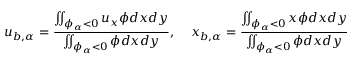<formula> <loc_0><loc_0><loc_500><loc_500>u _ { b , \alpha } = \frac { \iint _ { \phi _ { \alpha } < 0 } u _ { x } \phi d x d y } { \iint _ { \phi _ { \alpha } < 0 } \phi d x d y } , \, x _ { b , \alpha } = \frac { \iint _ { \phi _ { \alpha } < 0 } x \phi d x d y } { \iint _ { \phi _ { \alpha } < 0 } \phi d x d y }</formula> 